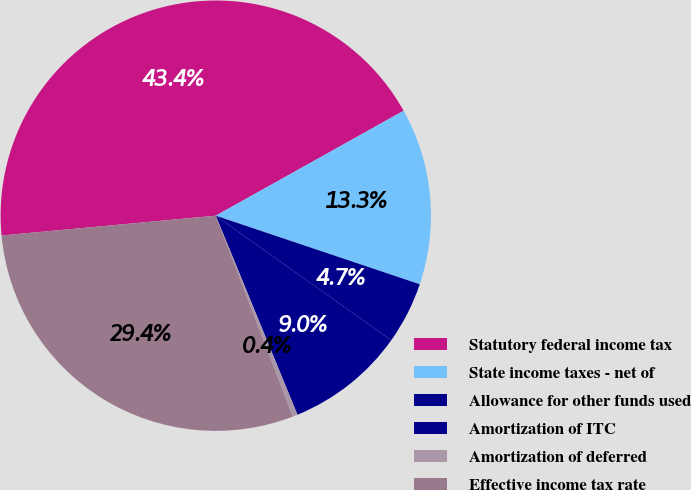Convert chart to OTSL. <chart><loc_0><loc_0><loc_500><loc_500><pie_chart><fcel>Statutory federal income tax<fcel>State income taxes - net of<fcel>Allowance for other funds used<fcel>Amortization of ITC<fcel>Amortization of deferred<fcel>Effective income tax rate<nl><fcel>43.36%<fcel>13.27%<fcel>4.67%<fcel>8.97%<fcel>0.37%<fcel>29.36%<nl></chart> 